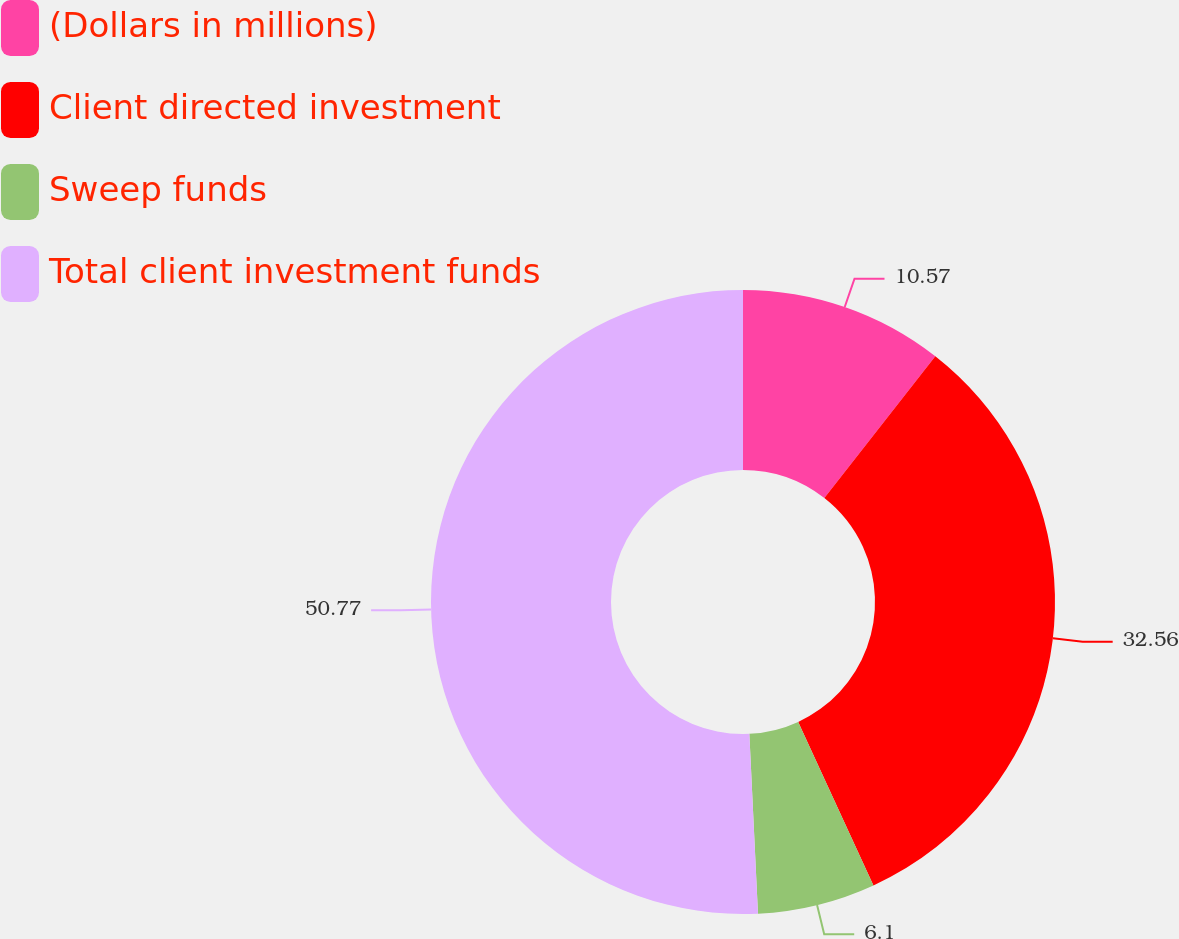<chart> <loc_0><loc_0><loc_500><loc_500><pie_chart><fcel>(Dollars in millions)<fcel>Client directed investment<fcel>Sweep funds<fcel>Total client investment funds<nl><fcel>10.57%<fcel>32.56%<fcel>6.1%<fcel>50.76%<nl></chart> 